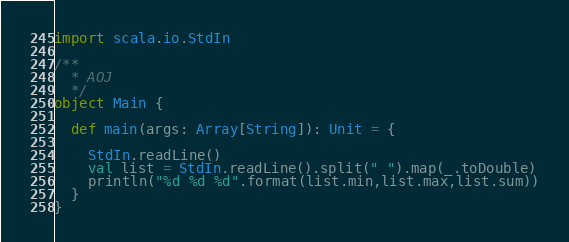Convert code to text. <code><loc_0><loc_0><loc_500><loc_500><_Scala_>import scala.io.StdIn

/**
  * AOJ
  */
object Main {

  def main(args: Array[String]): Unit = {

    StdIn.readLine()
    val list = StdIn.readLine().split(" ").map(_.toDouble)
    println("%d %d %d".format(list.min,list.max,list.sum))
  }
}</code> 